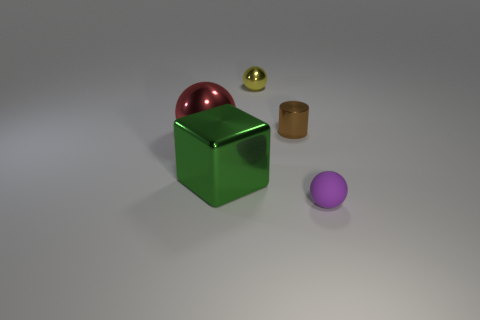Subtract all cylinders. How many objects are left? 4 Add 2 brown metal cylinders. How many objects exist? 7 Add 4 small brown cylinders. How many small brown cylinders are left? 5 Add 5 matte things. How many matte things exist? 6 Subtract 1 brown cylinders. How many objects are left? 4 Subtract all tiny gray metal things. Subtract all tiny yellow metallic balls. How many objects are left? 4 